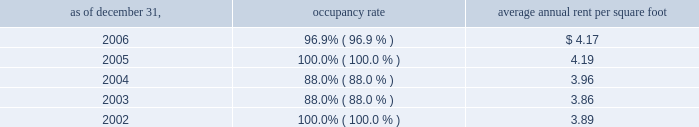Properties 51vornado realty trust industrial properties our dry warehouse/industrial properties consist of seven buildings in new jersey containing approximately 1.5 million square feet .
The properties are encumbered by two cross-collateralized mortgage loans aggregating $ 47179000 as of december 31 , 2006 .
Average lease terms range from three to five years .
The table sets forth the occupancy rate and average annual rent per square foot at the end of each of the past five years .
Average annual occupancy rent per as of december 31 , rate square foot .
220 central park south , new york city we own a 90% ( 90 % ) interest in 220 central park south .
The property contains 122 rental apartments with an aggregate of 133000 square feet and 5700 square feet of commercial space .
On november 7 , 2006 , we completed a $ 130000000 refinancing of the property .
The loan has two tranches : the first tranche of $ 95000000 bears interest at libor ( capped at 5.50% ( 5.50 % ) ) plus 2.35% ( 2.35 % ) ( 7.70% ( 7.70 % ) as of december 31 , 2006 ) and the second tranche can be drawn up to $ 35000000 and bears interest at libor ( capped at 5.50% ( 5.50 % ) ) plus 2.45% ( 2.45 % ) ( 7.80% ( 7.80 % ) as of december 31 , 2006 ) .
As of december 31 , 2006 , approximately $ 27990000 has been drawn on the second tranche .
40 east 66th street , new york city 40 east 66th street , located at madison avenue and east 66th street , contains 37 rental apartments with an aggregate of 85000 square feet , and 10000 square feet of retail space .
The rental apartment operations are included in our other segment and the retail operations are included in the retail segment. .
For the 2006 refinancing , as of december 31 , 2006 , approximately what percentage as been drawn on the second tranche? 
Computations: (27990000 / 35000000)
Answer: 0.79971. 